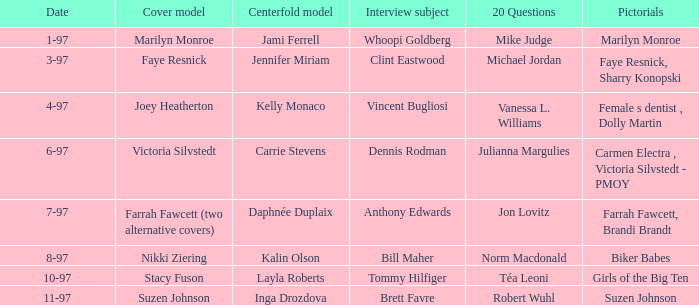What is the name of the cover model on 3-97? Faye Resnick. 